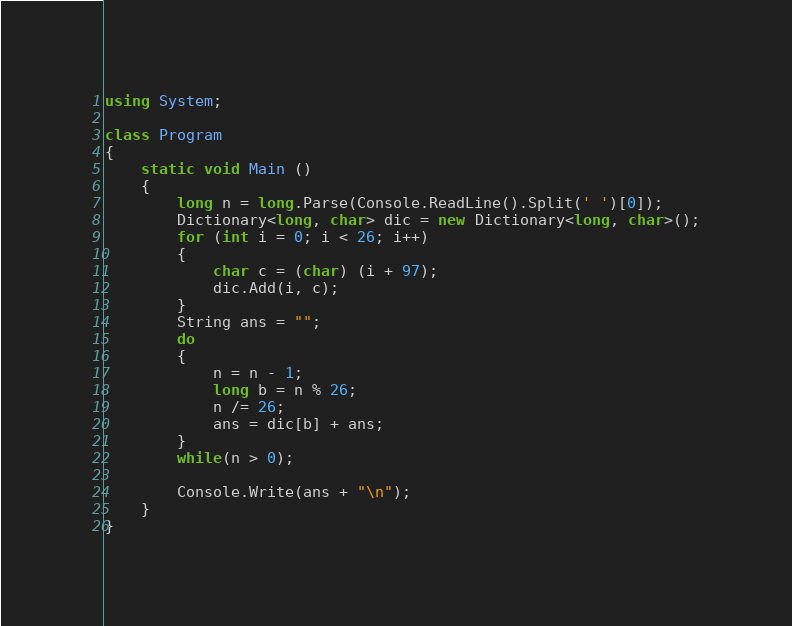<code> <loc_0><loc_0><loc_500><loc_500><_C#_>using System;

class Program
{
    static void Main () 
    {
        long n = long.Parse(Console.ReadLine().Split(' ')[0]);
        Dictionary<long, char> dic = new Dictionary<long, char>();
        for (int i = 0; i < 26; i++)
        {
            char c = (char) (i + 97);
            dic.Add(i, c);
        }
        String ans = "";
        do
        {
            n = n - 1;
            long b = n % 26;
            n /= 26;
            ans = dic[b] + ans;
        }
        while(n > 0);

        Console.Write(ans + "\n");
    }
}</code> 